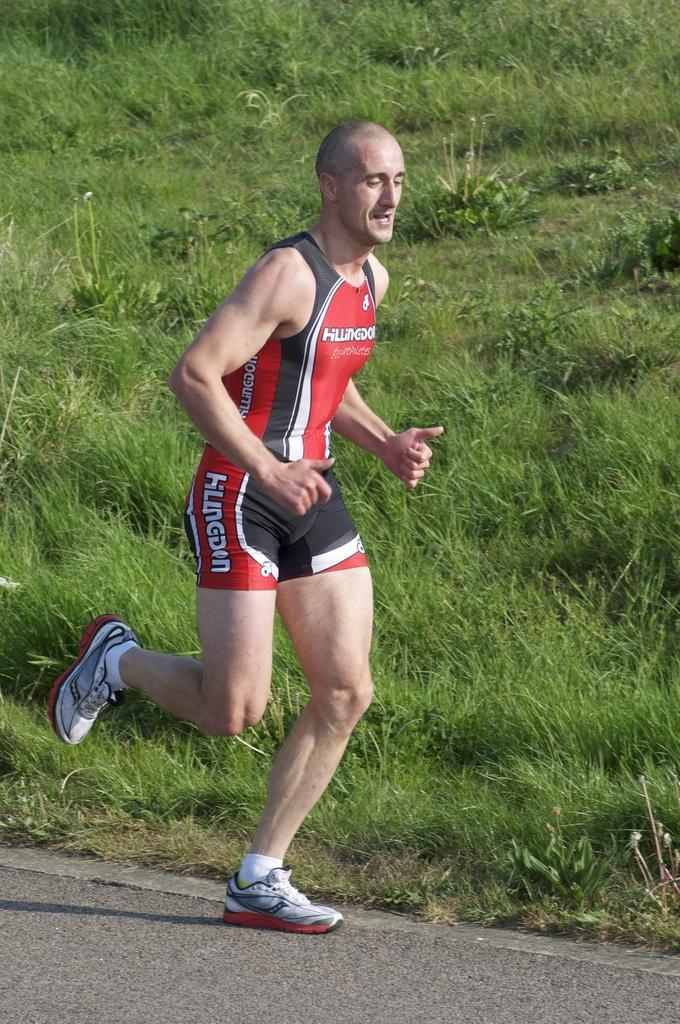<image>
Share a concise interpretation of the image provided. A runner has the word triathletes on the chest of his shirt. 